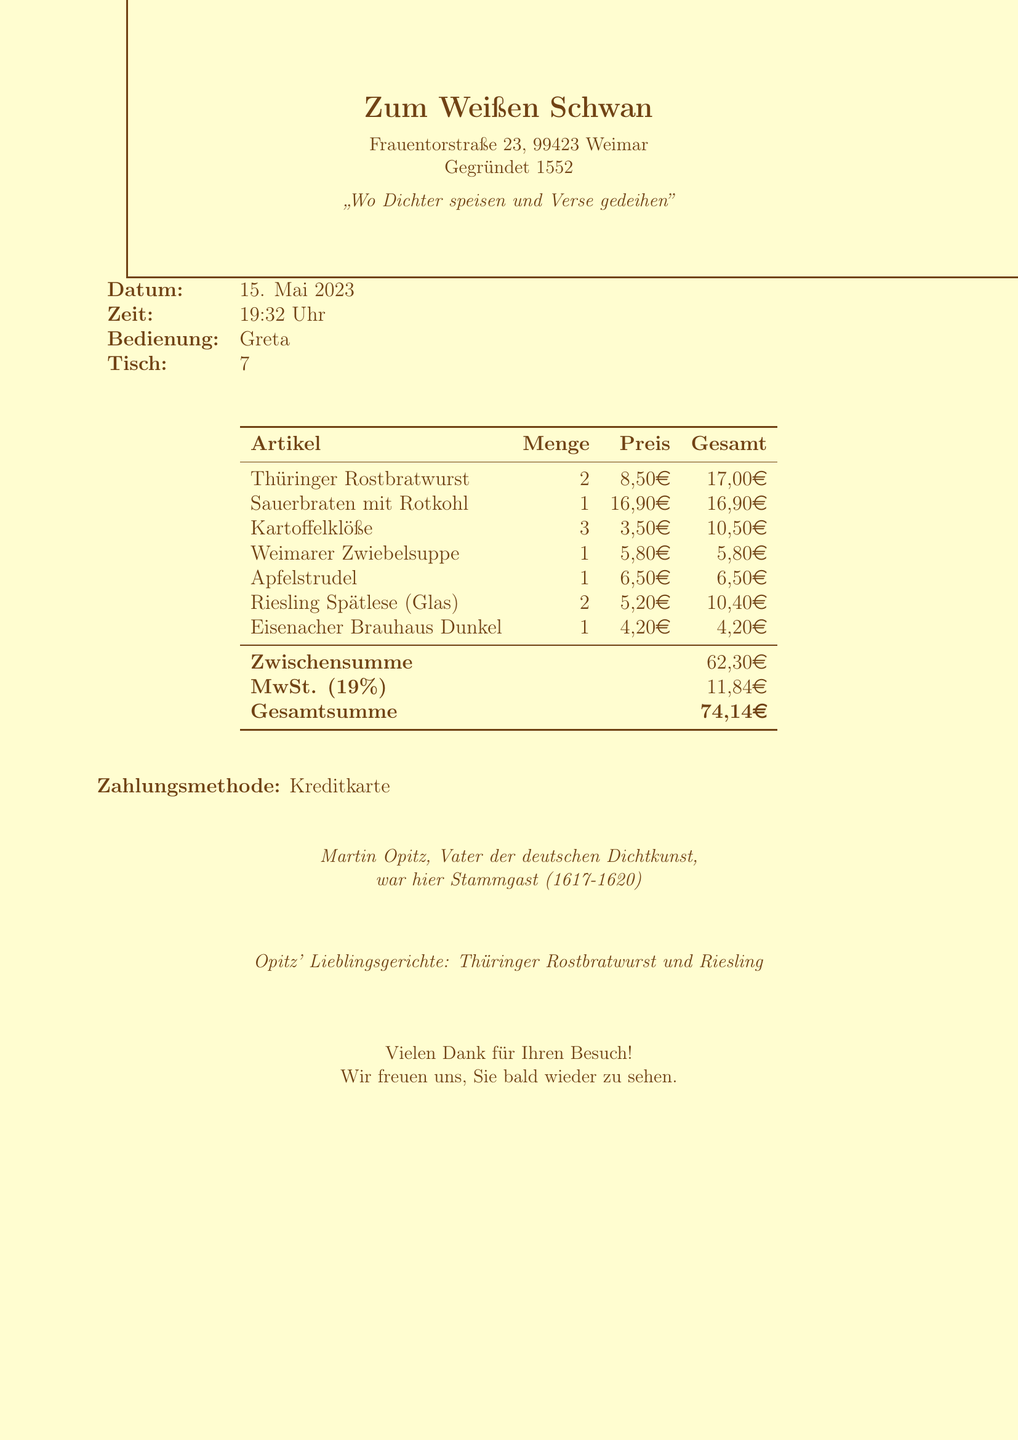What is the name of the restaurant? The restaurant's name is clearly stated in the document.
Answer: Zum Weißen Schwan When was the receipt dated? The date is provided in the document under the 'Datum' section.
Answer: 15. Mai 2023 Who was the server for this table? The name of the server is mentioned in the section labeled 'Bedienung'.
Answer: Greta How much did the Sauerbraten mit Rotkohl cost? The price of the Sauerbraten is detailed under the itemized list of items.
Answer: 16,90 Euro What is the total amount on the receipt? The total amount is summed up at the end in the 'Gesamtsumme' section.
Answer: 74,14 Euro What type of payment was used? The payment method is specified at the end of the receipt under 'Zahlungsmethode'.
Answer: Kreditkarte Which dish was listed as Martin Opitz's favorite? The favorite dish is mentioned in the historical note at the bottom of the receipt.
Answer: Thüringer Rostbratwurst In what year was the tavern established? The establishment year is indicated under the header of the document.
Answer: 1552 How many Potato Dumplings were ordered? The quantity of Kartoffelklöße is listed in the items table.
Answer: 3 